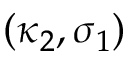Convert formula to latex. <formula><loc_0><loc_0><loc_500><loc_500>( \kappa _ { 2 } , \sigma _ { 1 } )</formula> 